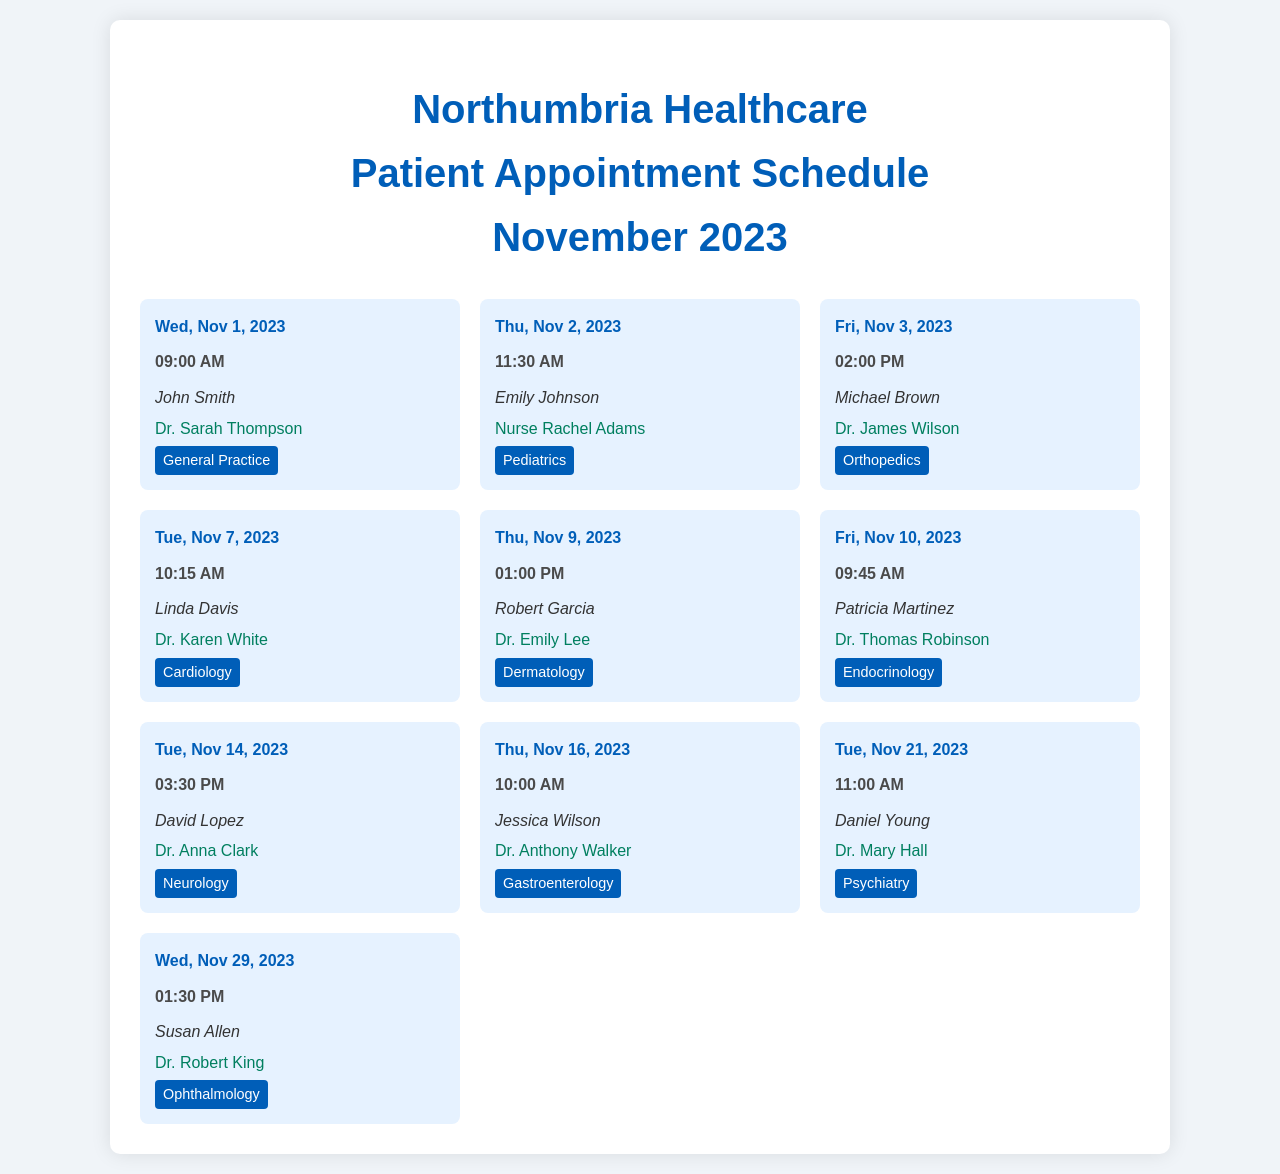What is the date of Michael Brown's appointment? The date is specified in Michael Brown's appointment details.
Answer: Fri, Nov 3, 2023 Who is the healthcare professional attending to Susan Allen? The professional's name is noted in the appointment for Susan Allen.
Answer: Dr. Robert King What time is Linda Davis's appointment scheduled? The time is clearly stated in Linda Davis's appointment entry.
Answer: 10:15 AM Which department is Dr. Karen White associated with? The department is mentioned in the appointment for Linda Davis with Dr. Karen White.
Answer: Cardiology How many appointments are scheduled on November 14, 2023? The document lists the number of appointments for that date.
Answer: 1 What type of professional is in charge of Emily Johnson's appointment? The type of professional is identified in Emily Johnson's appointment details.
Answer: Nurse Which patient has an appointment with Dr. Thomas Robinson? The patient name is listed under Dr. Thomas Robinson's appointment details.
Answer: Patricia Martinez On which date does Daniel Young have an appointment? The specific date is included in Daniel Young's appointment information.
Answer: Tue, Nov 21, 2023 What time is the appointment for Jessica Wilson? The time is stated in the details of Jessica Wilson's appointment.
Answer: 10:00 AM 